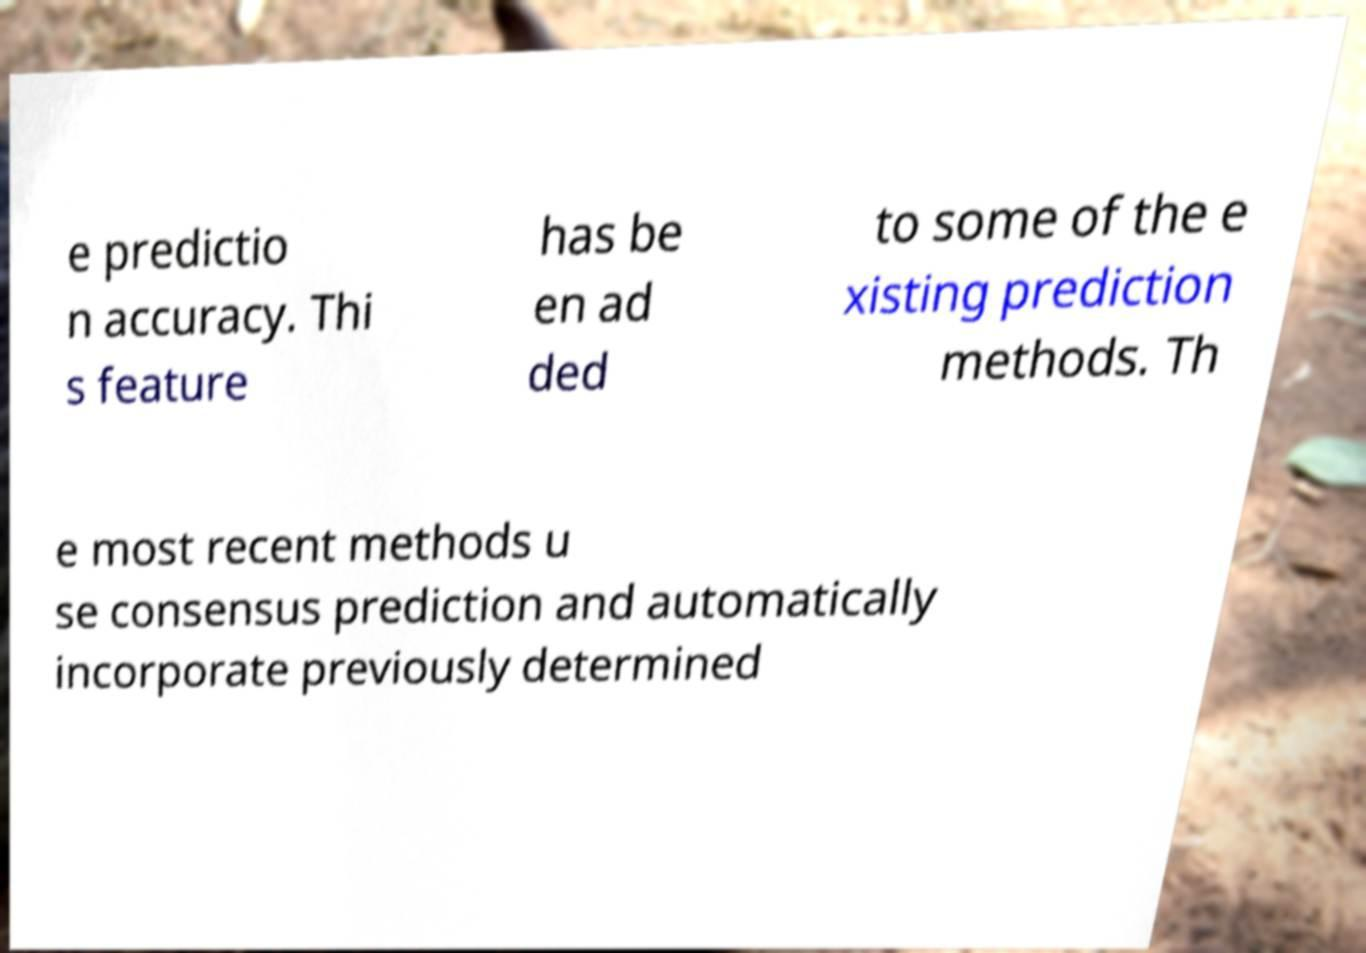What messages or text are displayed in this image? I need them in a readable, typed format. e predictio n accuracy. Thi s feature has be en ad ded to some of the e xisting prediction methods. Th e most recent methods u se consensus prediction and automatically incorporate previously determined 